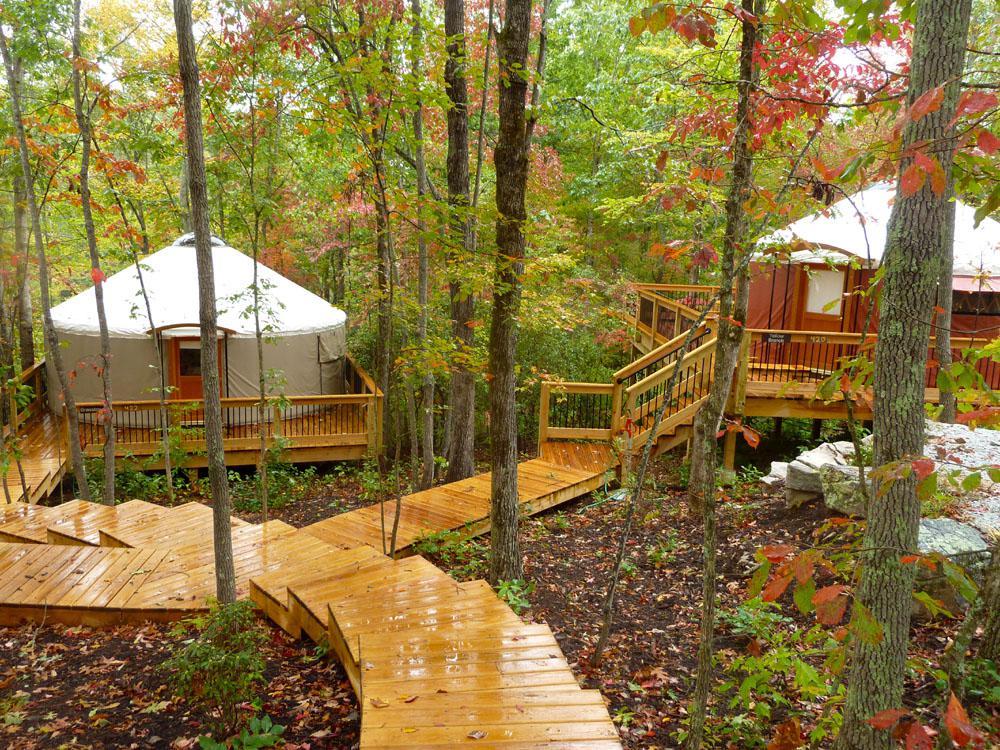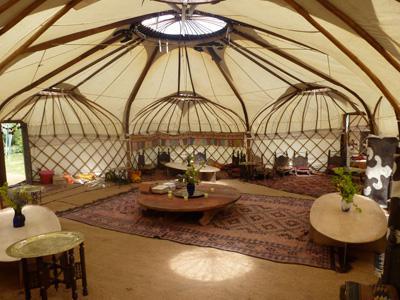The first image is the image on the left, the second image is the image on the right. Considering the images on both sides, is "One image shows the interior of a large yurt with the framework of three small side-by-side yurts in the rear and a skylight overhead." valid? Answer yes or no. Yes. The first image is the image on the left, the second image is the image on the right. For the images shown, is this caption "An image shows an interior with three side-by-side lattice-work dome-topped structural elements visible." true? Answer yes or no. Yes. 